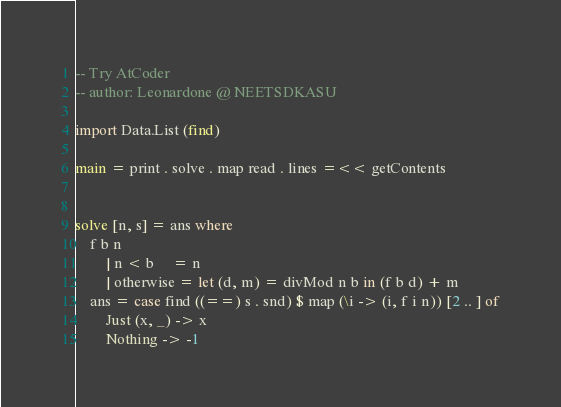<code> <loc_0><loc_0><loc_500><loc_500><_Haskell_>-- Try AtCoder
-- author: Leonardone @ NEETSDKASU

import Data.List (find)

main = print . solve . map read . lines =<< getContents


solve [n, s] = ans where
    f b n
        | n < b     = n
        | otherwise = let (d, m) = divMod n b in (f b d) + m
    ans = case find ((==) s . snd) $ map (\i -> (i, f i n)) [2 .. ] of
        Just (x, _) -> x
        Nothing -> -1
</code> 